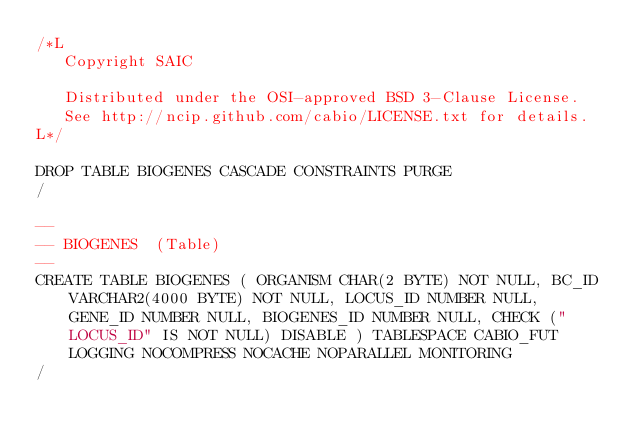Convert code to text. <code><loc_0><loc_0><loc_500><loc_500><_SQL_>/*L
   Copyright SAIC

   Distributed under the OSI-approved BSD 3-Clause License.
   See http://ncip.github.com/cabio/LICENSE.txt for details.
L*/

DROP TABLE BIOGENES CASCADE CONSTRAINTS PURGE
/

--
-- BIOGENES  (Table) 
--
CREATE TABLE BIOGENES ( ORGANISM CHAR(2 BYTE) NOT NULL, BC_ID VARCHAR2(4000 BYTE) NOT NULL, LOCUS_ID NUMBER NULL, GENE_ID NUMBER NULL, BIOGENES_ID NUMBER NULL, CHECK ("LOCUS_ID" IS NOT NULL) DISABLE ) TABLESPACE CABIO_FUT LOGGING NOCOMPRESS NOCACHE NOPARALLEL MONITORING
/


</code> 